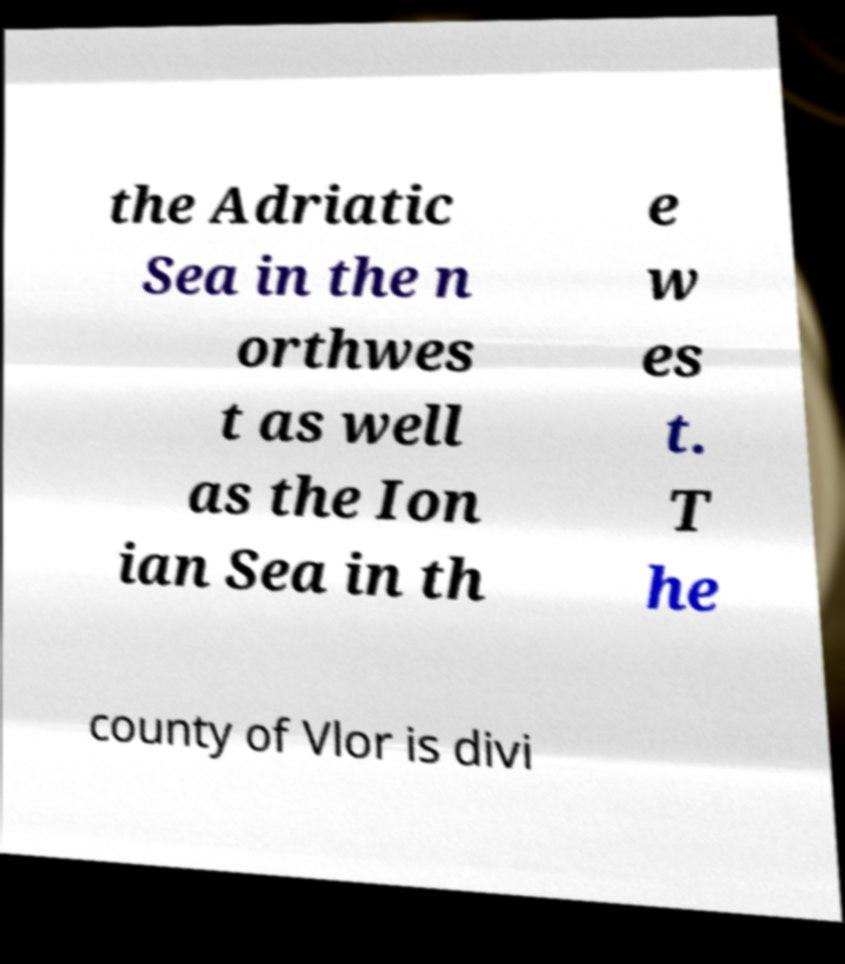There's text embedded in this image that I need extracted. Can you transcribe it verbatim? the Adriatic Sea in the n orthwes t as well as the Ion ian Sea in th e w es t. T he county of Vlor is divi 